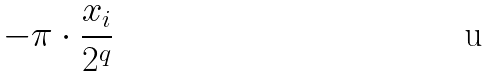<formula> <loc_0><loc_0><loc_500><loc_500>- \pi \cdot \frac { x _ { i } } { 2 ^ { q } }</formula> 